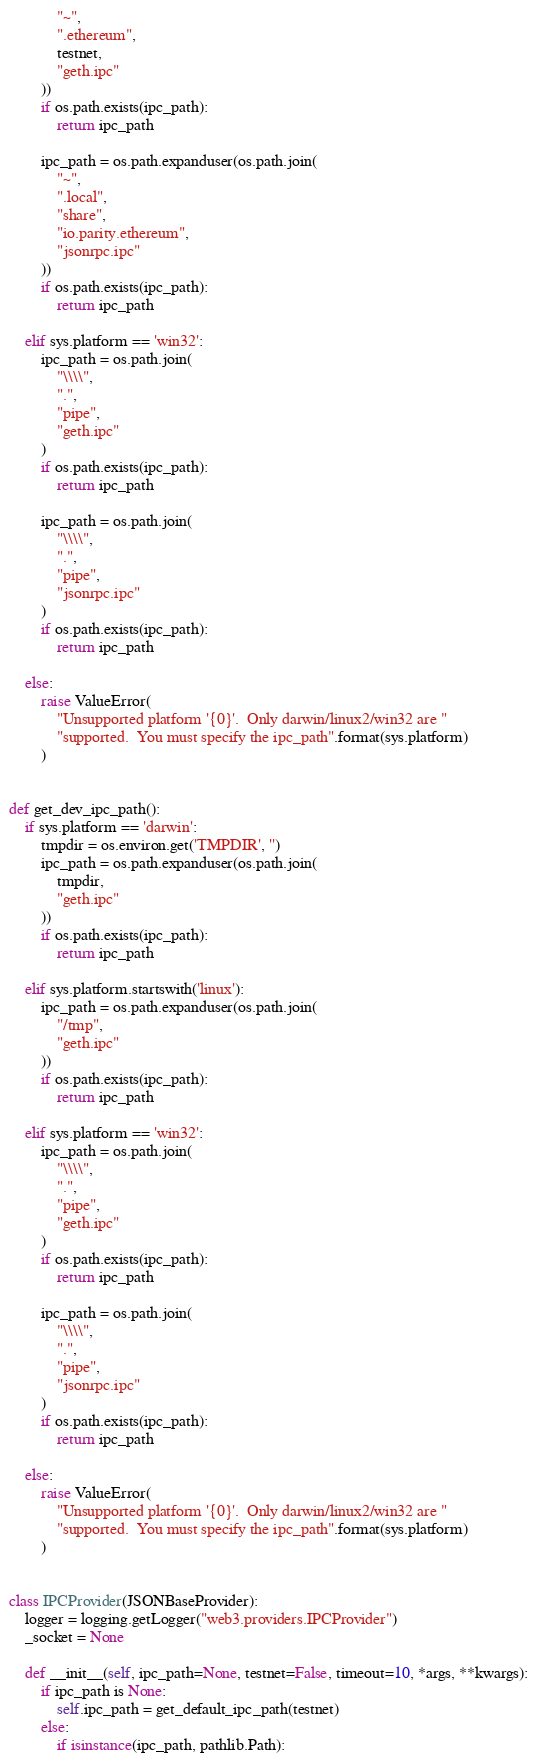<code> <loc_0><loc_0><loc_500><loc_500><_Python_>            "~",
            ".ethereum",
            testnet,
            "geth.ipc"
        ))
        if os.path.exists(ipc_path):
            return ipc_path

        ipc_path = os.path.expanduser(os.path.join(
            "~",
            ".local",
            "share",
            "io.parity.ethereum",
            "jsonrpc.ipc"
        ))
        if os.path.exists(ipc_path):
            return ipc_path

    elif sys.platform == 'win32':
        ipc_path = os.path.join(
            "\\\\",
            ".",
            "pipe",
            "geth.ipc"
        )
        if os.path.exists(ipc_path):
            return ipc_path

        ipc_path = os.path.join(
            "\\\\",
            ".",
            "pipe",
            "jsonrpc.ipc"
        )
        if os.path.exists(ipc_path):
            return ipc_path

    else:
        raise ValueError(
            "Unsupported platform '{0}'.  Only darwin/linux2/win32 are "
            "supported.  You must specify the ipc_path".format(sys.platform)
        )


def get_dev_ipc_path():
    if sys.platform == 'darwin':
        tmpdir = os.environ.get('TMPDIR', '')
        ipc_path = os.path.expanduser(os.path.join(
            tmpdir,
            "geth.ipc"
        ))
        if os.path.exists(ipc_path):
            return ipc_path

    elif sys.platform.startswith('linux'):
        ipc_path = os.path.expanduser(os.path.join(
            "/tmp",
            "geth.ipc"
        ))
        if os.path.exists(ipc_path):
            return ipc_path

    elif sys.platform == 'win32':
        ipc_path = os.path.join(
            "\\\\",
            ".",
            "pipe",
            "geth.ipc"
        )
        if os.path.exists(ipc_path):
            return ipc_path

        ipc_path = os.path.join(
            "\\\\",
            ".",
            "pipe",
            "jsonrpc.ipc"
        )
        if os.path.exists(ipc_path):
            return ipc_path

    else:
        raise ValueError(
            "Unsupported platform '{0}'.  Only darwin/linux2/win32 are "
            "supported.  You must specify the ipc_path".format(sys.platform)
        )


class IPCProvider(JSONBaseProvider):
    logger = logging.getLogger("web3.providers.IPCProvider")
    _socket = None

    def __init__(self, ipc_path=None, testnet=False, timeout=10, *args, **kwargs):
        if ipc_path is None:
            self.ipc_path = get_default_ipc_path(testnet)
        else:
            if isinstance(ipc_path, pathlib.Path):</code> 